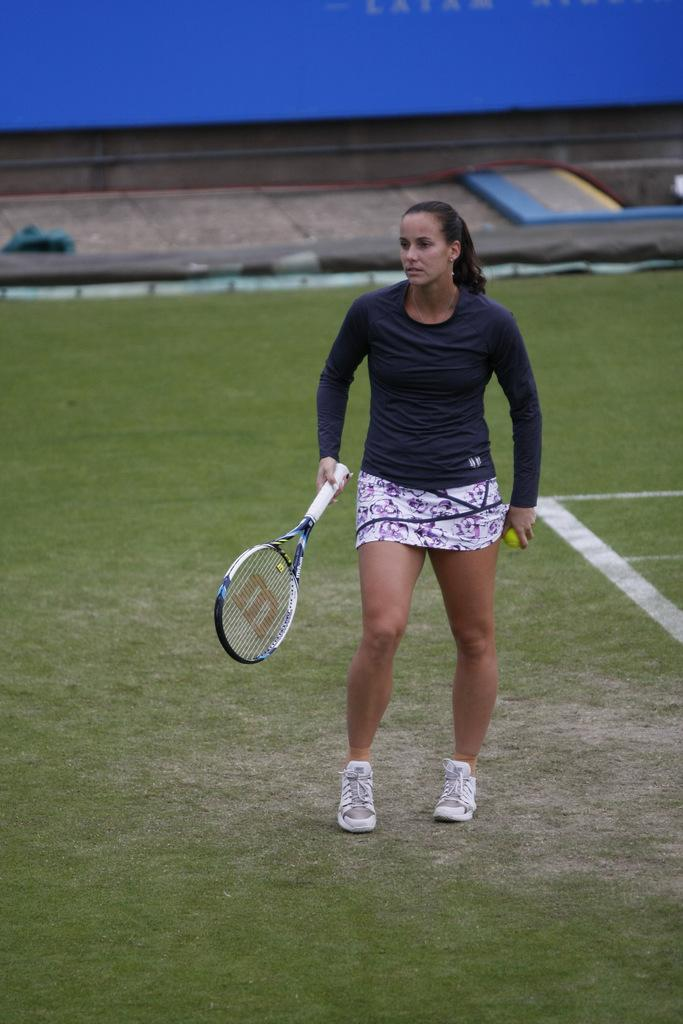Who is present in the image? There is a woman in the image. What is the woman doing in the image? The woman is standing on the ground and holding a racket with her hand. What is the surface beneath the woman's feet? The ground is covered with grass. What type of paper is the woman reading in the image? There is no paper present in the image; the woman is holding a racket. 